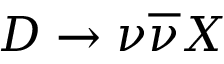<formula> <loc_0><loc_0><loc_500><loc_500>D \to \nu \overline { \nu } X</formula> 